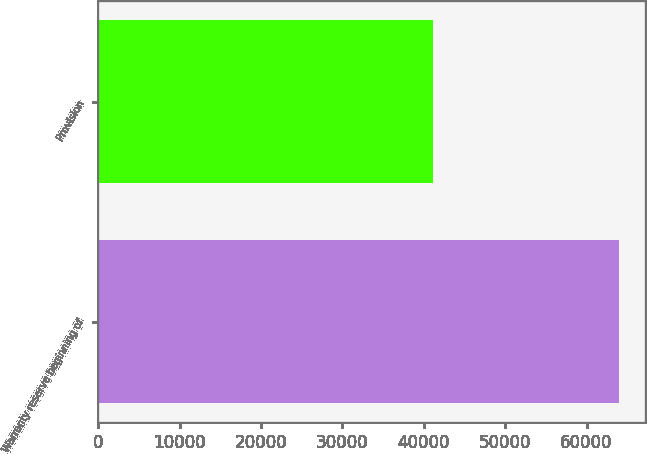Convert chart to OTSL. <chart><loc_0><loc_0><loc_500><loc_500><bar_chart><fcel>Warranty reserve beginning of<fcel>Provision<nl><fcel>64008<fcel>41138<nl></chart> 